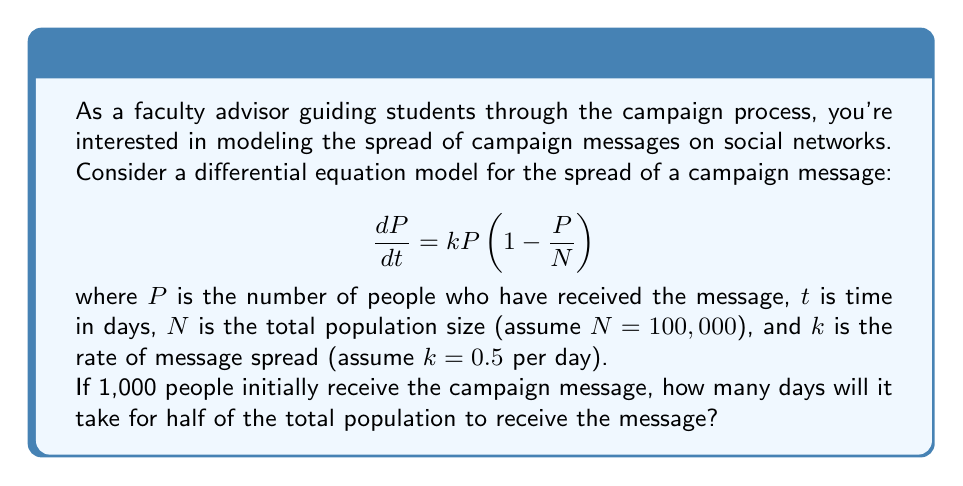Solve this math problem. To solve this problem, we need to integrate the logistic differential equation and then solve for the time when $P = 50,000$ (half of the total population).

1) The logistic differential equation has the following solution:

   $$P(t) = \frac{N}{1 + (\frac{N}{P_0} - 1)e^{-kt}}$$

   where $P_0$ is the initial number of people who received the message.

2) Substituting the given values:
   $N = 100,000$, $k = 0.5$, $P_0 = 1,000$

3) We want to find $t$ when $P(t) = 50,000$:

   $$50,000 = \frac{100,000}{1 + (\frac{100,000}{1,000} - 1)e^{-0.5t}}$$

4) Simplify:
   $$\frac{1}{2} = \frac{1}{1 + 99e^{-0.5t}}$$

5) Solve for $t$:
   $$1 + 99e^{-0.5t} = 2$$
   $$99e^{-0.5t} = 1$$
   $$e^{-0.5t} = \frac{1}{99}$$
   $$-0.5t = \ln(\frac{1}{99})$$
   $$t = -\frac{2}{0.5}\ln(\frac{1}{99}) = 2\ln(99) \approx 9.19$$

Therefore, it will take approximately 9.19 days for half of the population to receive the campaign message.
Answer: $t \approx 9.19$ days 